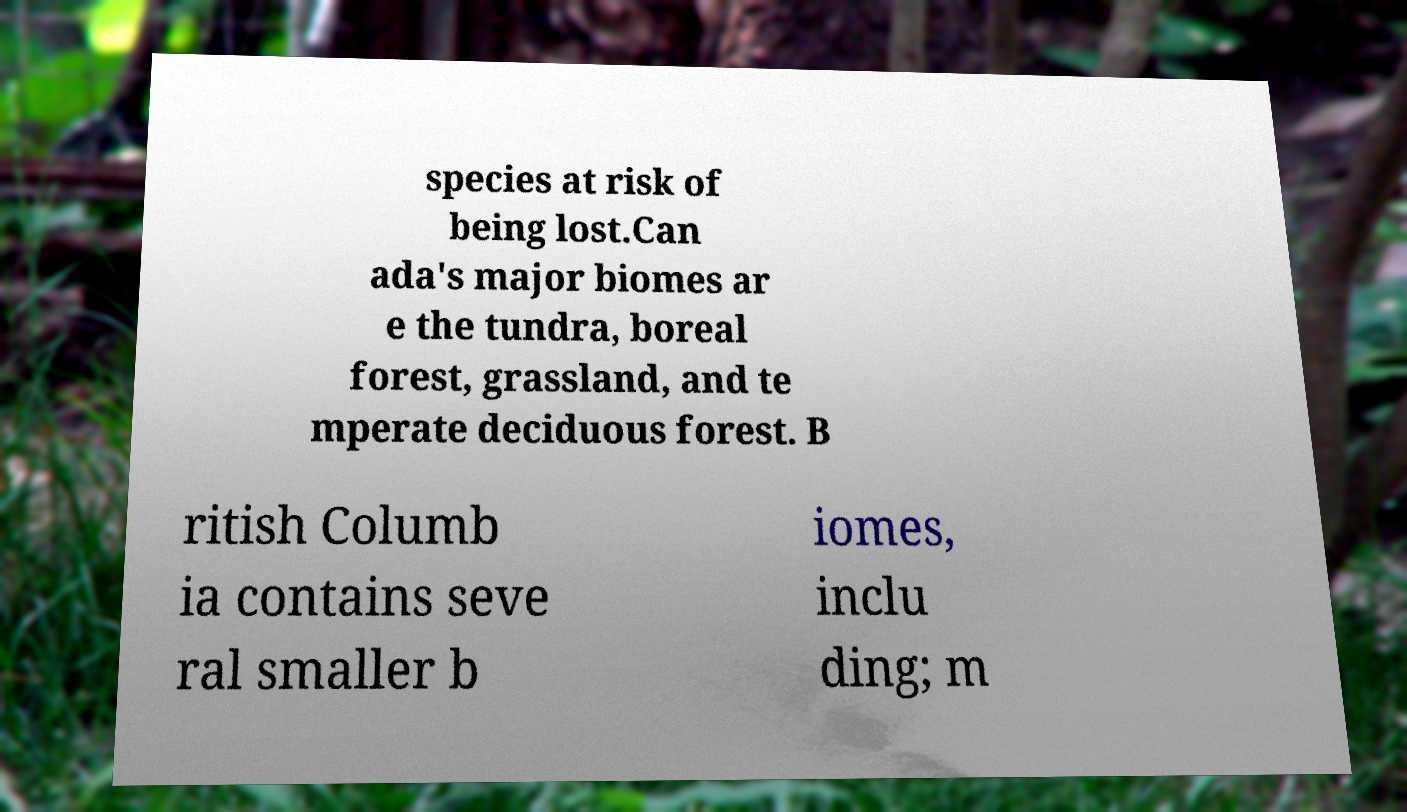Could you extract and type out the text from this image? species at risk of being lost.Can ada's major biomes ar e the tundra, boreal forest, grassland, and te mperate deciduous forest. B ritish Columb ia contains seve ral smaller b iomes, inclu ding; m 